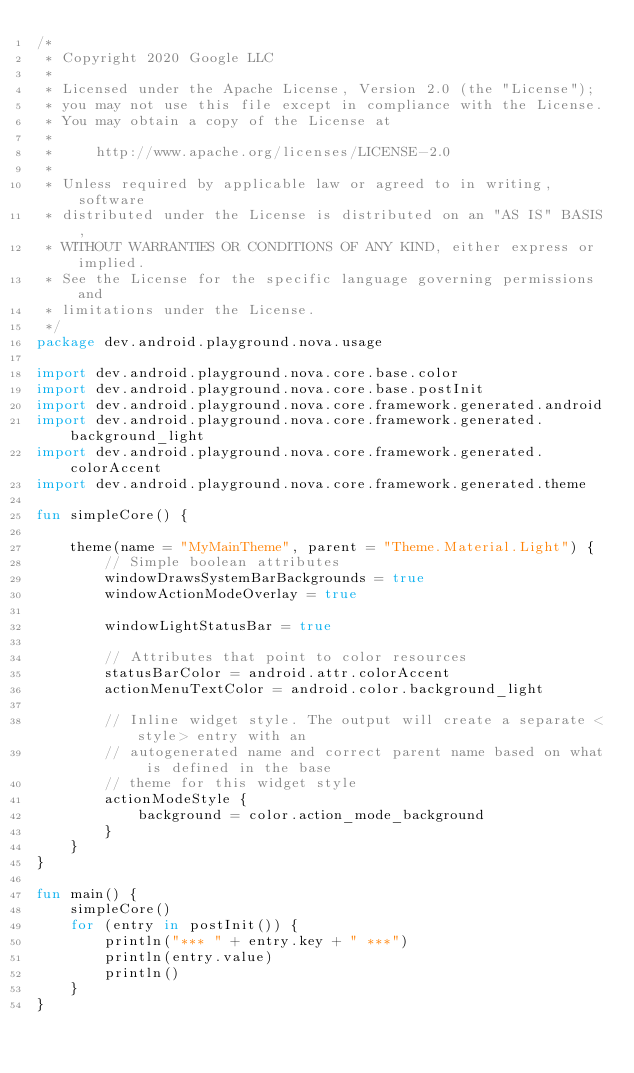<code> <loc_0><loc_0><loc_500><loc_500><_Kotlin_>/*
 * Copyright 2020 Google LLC
 *
 * Licensed under the Apache License, Version 2.0 (the "License");
 * you may not use this file except in compliance with the License.
 * You may obtain a copy of the License at
 *
 *     http://www.apache.org/licenses/LICENSE-2.0
 *
 * Unless required by applicable law or agreed to in writing, software
 * distributed under the License is distributed on an "AS IS" BASIS,
 * WITHOUT WARRANTIES OR CONDITIONS OF ANY KIND, either express or implied.
 * See the License for the specific language governing permissions and
 * limitations under the License.
 */
package dev.android.playground.nova.usage

import dev.android.playground.nova.core.base.color
import dev.android.playground.nova.core.base.postInit
import dev.android.playground.nova.core.framework.generated.android
import dev.android.playground.nova.core.framework.generated.background_light
import dev.android.playground.nova.core.framework.generated.colorAccent
import dev.android.playground.nova.core.framework.generated.theme

fun simpleCore() {

    theme(name = "MyMainTheme", parent = "Theme.Material.Light") {
        // Simple boolean attributes
        windowDrawsSystemBarBackgrounds = true
        windowActionModeOverlay = true

        windowLightStatusBar = true

        // Attributes that point to color resources
        statusBarColor = android.attr.colorAccent
        actionMenuTextColor = android.color.background_light

        // Inline widget style. The output will create a separate <style> entry with an
        // autogenerated name and correct parent name based on what is defined in the base
        // theme for this widget style
        actionModeStyle {
            background = color.action_mode_background
        }
    }
}

fun main() {
    simpleCore()
    for (entry in postInit()) {
        println("*** " + entry.key + " ***")
        println(entry.value)
        println()
    }
}

</code> 